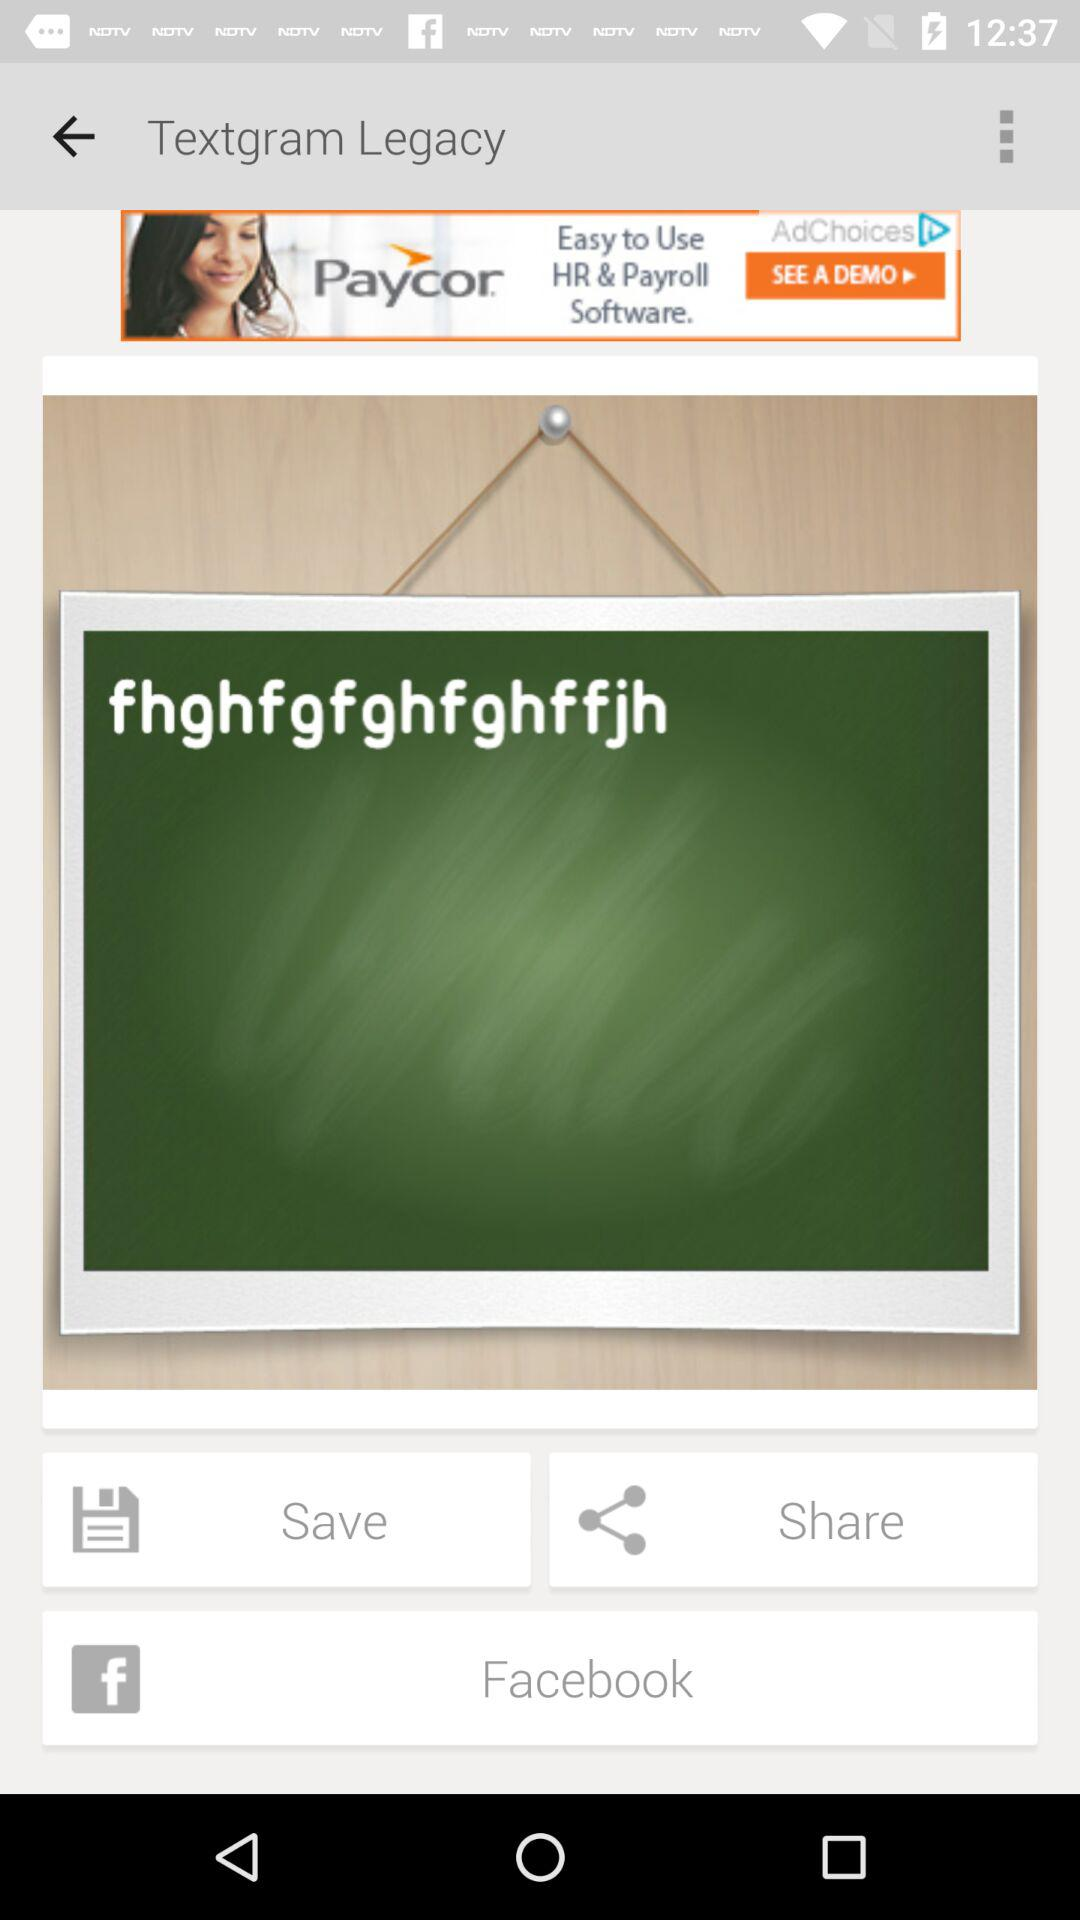Can we share with "Google+"?
When the provided information is insufficient, respond with <no answer>. <no answer> 